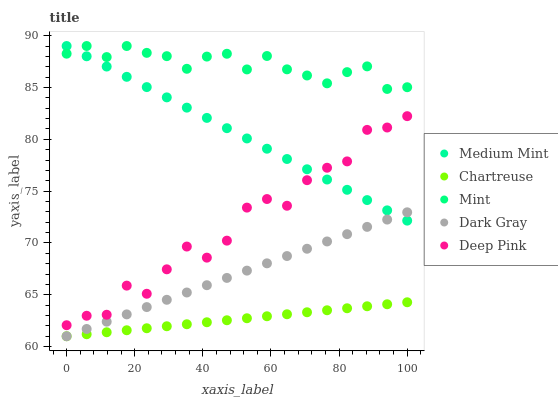Does Chartreuse have the minimum area under the curve?
Answer yes or no. Yes. Does Mint have the maximum area under the curve?
Answer yes or no. Yes. Does Dark Gray have the minimum area under the curve?
Answer yes or no. No. Does Dark Gray have the maximum area under the curve?
Answer yes or no. No. Is Chartreuse the smoothest?
Answer yes or no. Yes. Is Deep Pink the roughest?
Answer yes or no. Yes. Is Dark Gray the smoothest?
Answer yes or no. No. Is Dark Gray the roughest?
Answer yes or no. No. Does Dark Gray have the lowest value?
Answer yes or no. Yes. Does Deep Pink have the lowest value?
Answer yes or no. No. Does Mint have the highest value?
Answer yes or no. Yes. Does Dark Gray have the highest value?
Answer yes or no. No. Is Deep Pink less than Mint?
Answer yes or no. Yes. Is Mint greater than Dark Gray?
Answer yes or no. Yes. Does Dark Gray intersect Chartreuse?
Answer yes or no. Yes. Is Dark Gray less than Chartreuse?
Answer yes or no. No. Is Dark Gray greater than Chartreuse?
Answer yes or no. No. Does Deep Pink intersect Mint?
Answer yes or no. No. 